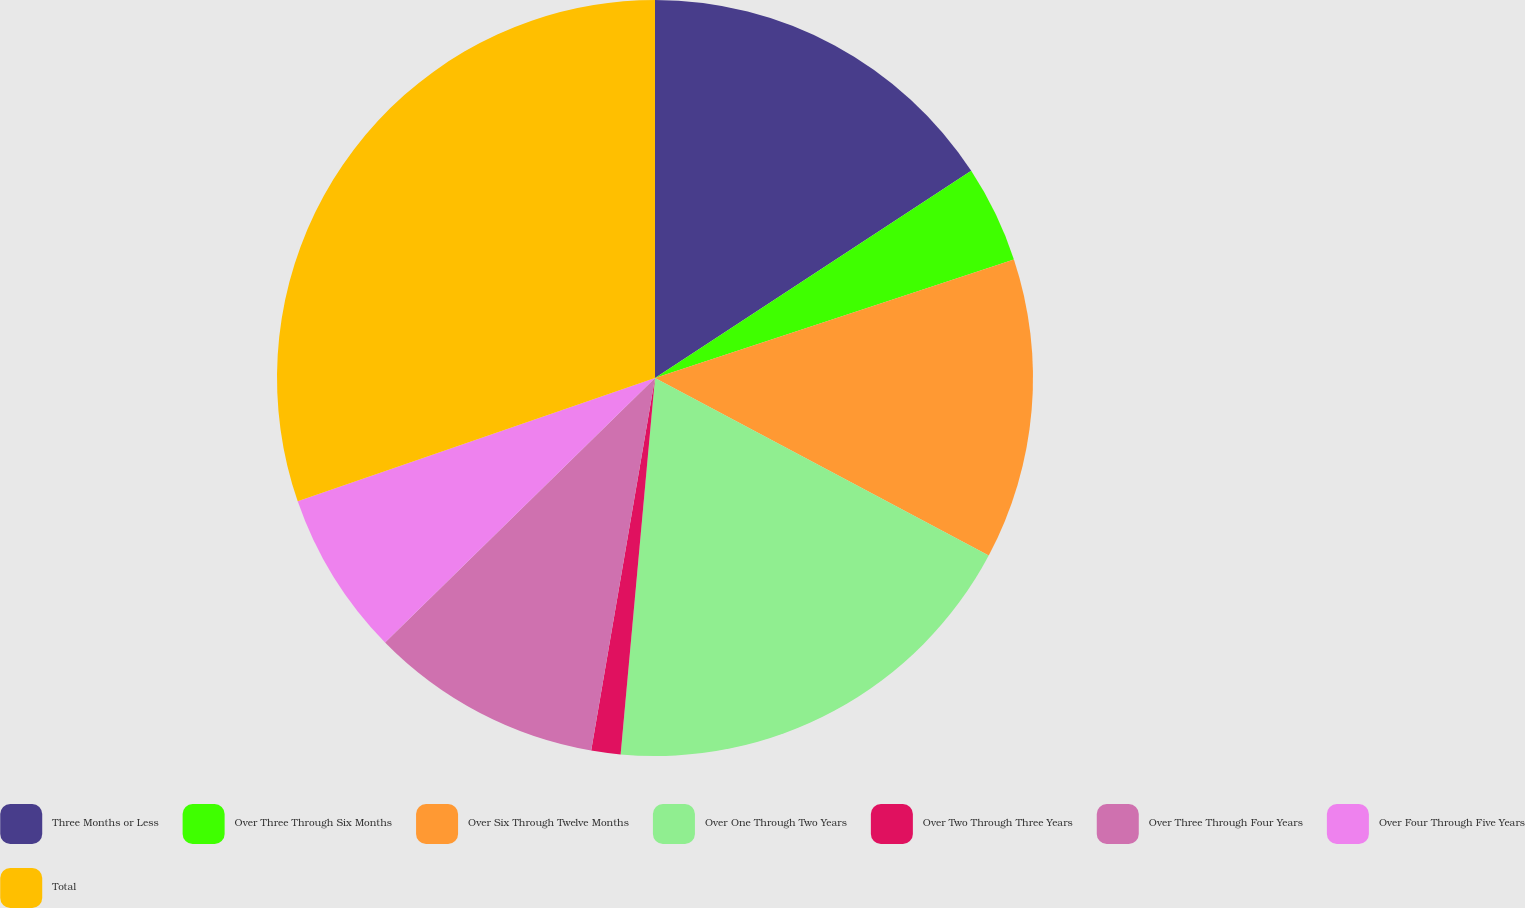Convert chart to OTSL. <chart><loc_0><loc_0><loc_500><loc_500><pie_chart><fcel>Three Months or Less<fcel>Over Three Through Six Months<fcel>Over Six Through Twelve Months<fcel>Over One Through Two Years<fcel>Over Two Through Three Years<fcel>Over Three Through Four Years<fcel>Over Four Through Five Years<fcel>Total<nl><fcel>15.77%<fcel>4.15%<fcel>12.86%<fcel>18.67%<fcel>1.25%<fcel>9.96%<fcel>7.05%<fcel>30.29%<nl></chart> 